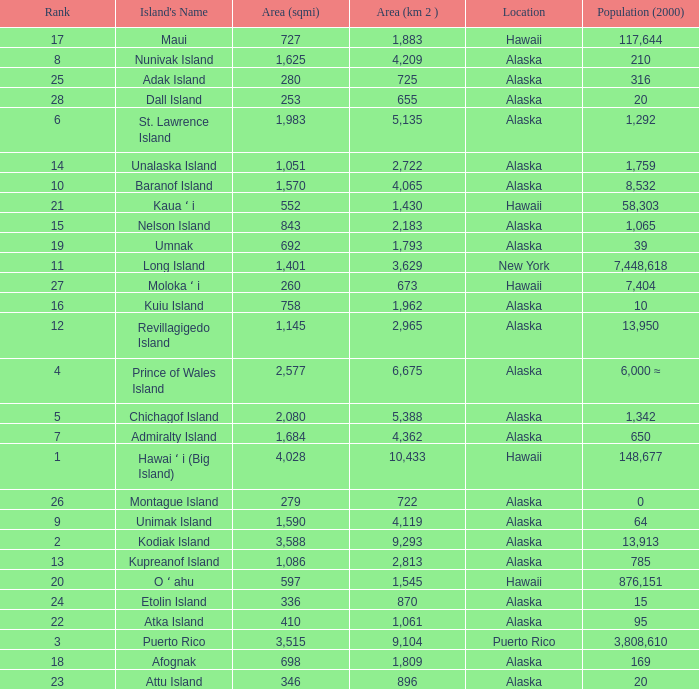What is the highest rank for Nelson Island with area more than 2,183? None. 